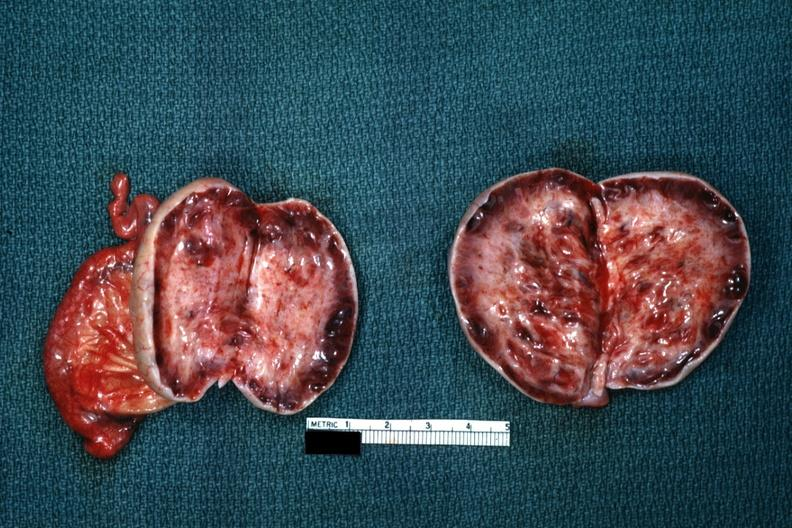what is present?
Answer the question using a single word or phrase. Stein leventhal 